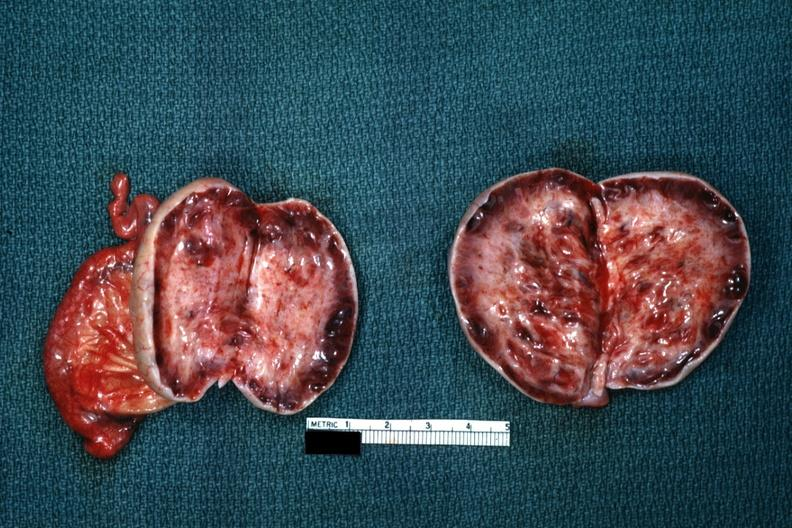what is present?
Answer the question using a single word or phrase. Stein leventhal 